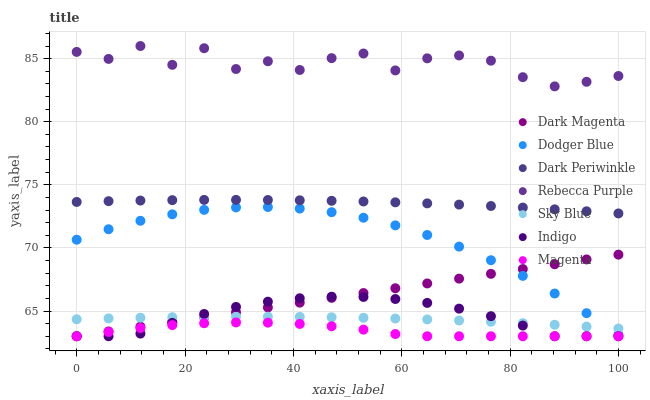Does Magenta have the minimum area under the curve?
Answer yes or no. Yes. Does Rebecca Purple have the maximum area under the curve?
Answer yes or no. Yes. Does Dark Magenta have the minimum area under the curve?
Answer yes or no. No. Does Dark Magenta have the maximum area under the curve?
Answer yes or no. No. Is Dark Magenta the smoothest?
Answer yes or no. Yes. Is Rebecca Purple the roughest?
Answer yes or no. Yes. Is Dodger Blue the smoothest?
Answer yes or no. No. Is Dodger Blue the roughest?
Answer yes or no. No. Does Indigo have the lowest value?
Answer yes or no. Yes. Does Dodger Blue have the lowest value?
Answer yes or no. No. Does Rebecca Purple have the highest value?
Answer yes or no. Yes. Does Dark Magenta have the highest value?
Answer yes or no. No. Is Magenta less than Sky Blue?
Answer yes or no. Yes. Is Rebecca Purple greater than Indigo?
Answer yes or no. Yes. Does Dark Magenta intersect Indigo?
Answer yes or no. Yes. Is Dark Magenta less than Indigo?
Answer yes or no. No. Is Dark Magenta greater than Indigo?
Answer yes or no. No. Does Magenta intersect Sky Blue?
Answer yes or no. No. 